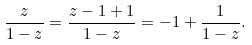<formula> <loc_0><loc_0><loc_500><loc_500>\frac { z } { 1 - z } = \frac { z - 1 + 1 } { 1 - z } = - 1 + \frac { 1 } { 1 - z } .</formula> 